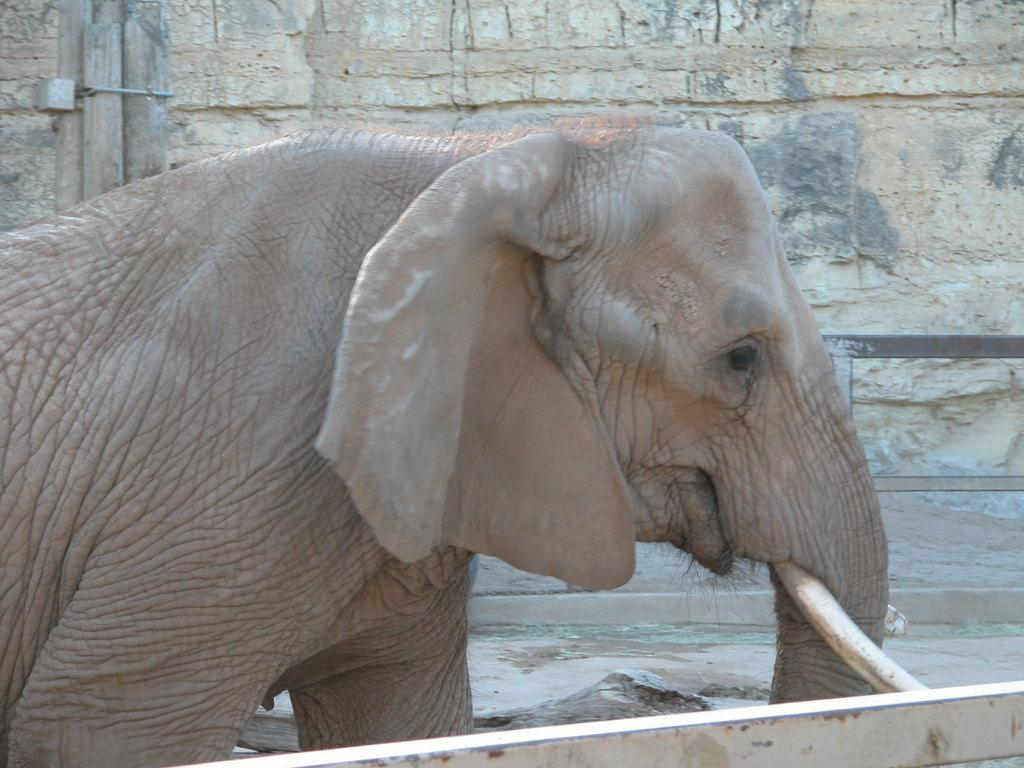What animal is present in the image? There is an elephant in the image. What can be seen in the background of the image? There is a wall in the background of the image. What type of stone is the elephant sneezing in the image? There is no stone present in the image, nor is the elephant sneezing. 